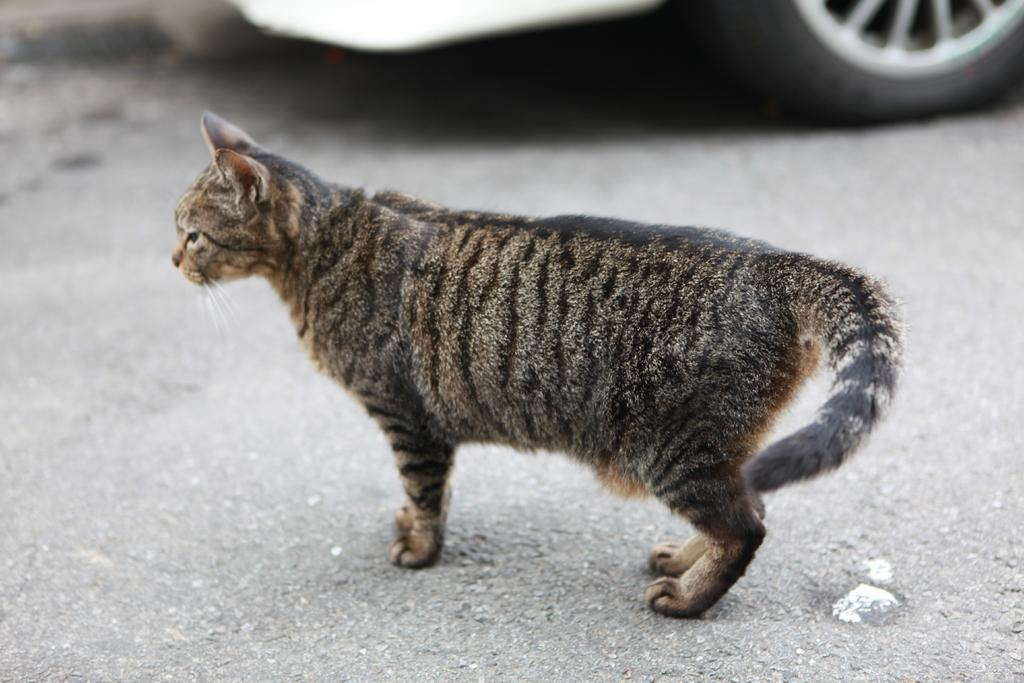What is the main subject in the center of the image? There is a cat in the center of the image. What other object can be seen at the top side of the image? There is a car at the top side of the image. What type of gun is being used by the cat in the image? There is no gun present in the image; it features a cat and a car. What is the purpose of the cat in the image? The purpose of the cat in the image cannot be determined without additional context or information. 